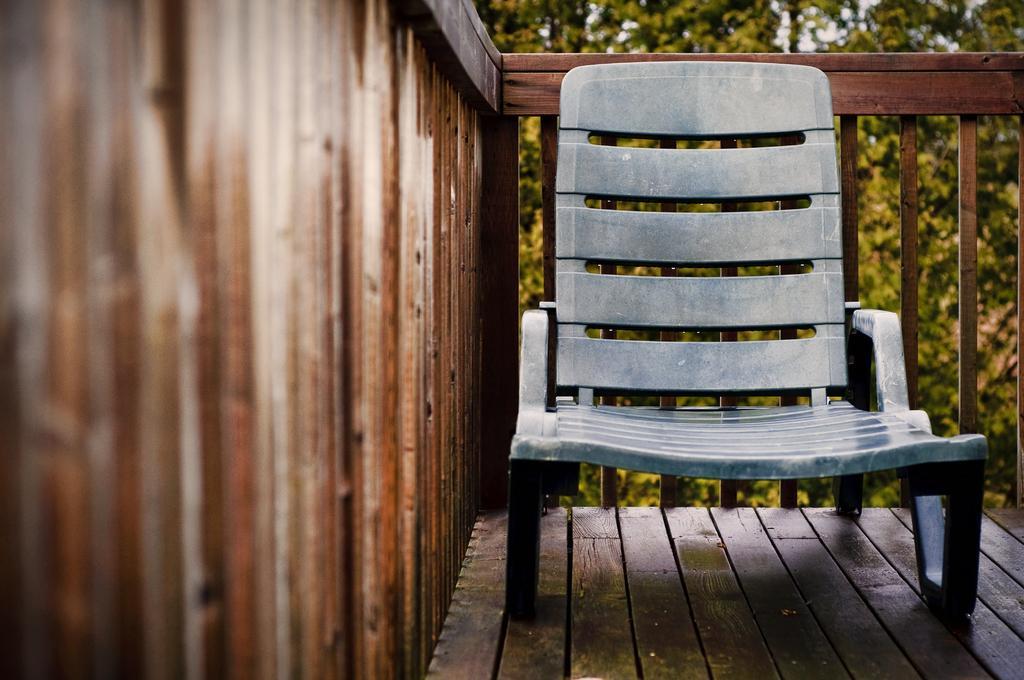Describe this image in one or two sentences. In this image, I can see a chair. This looks like a wooden fence. Here is the floor. In the background, I can see the trees. 